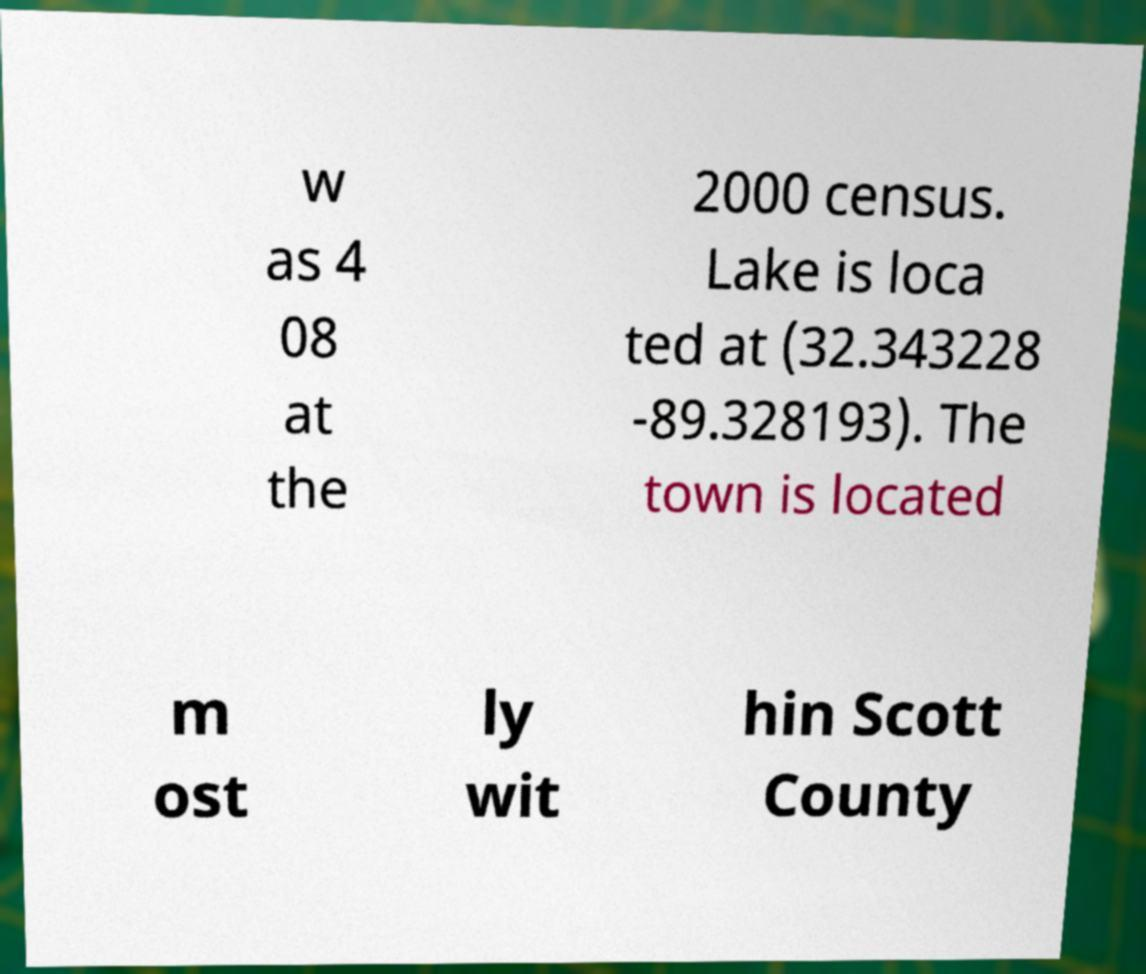Can you read and provide the text displayed in the image?This photo seems to have some interesting text. Can you extract and type it out for me? w as 4 08 at the 2000 census. Lake is loca ted at (32.343228 -89.328193). The town is located m ost ly wit hin Scott County 